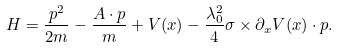<formula> <loc_0><loc_0><loc_500><loc_500>H = \frac { { p } ^ { 2 } } { 2 m } - \frac { { A } \cdot { p } } { m } + V ( { x } ) - \frac { \lambda _ { 0 } ^ { 2 } } { 4 } \sigma \times \partial _ { x } V ( { x } ) \cdot { p } .</formula> 